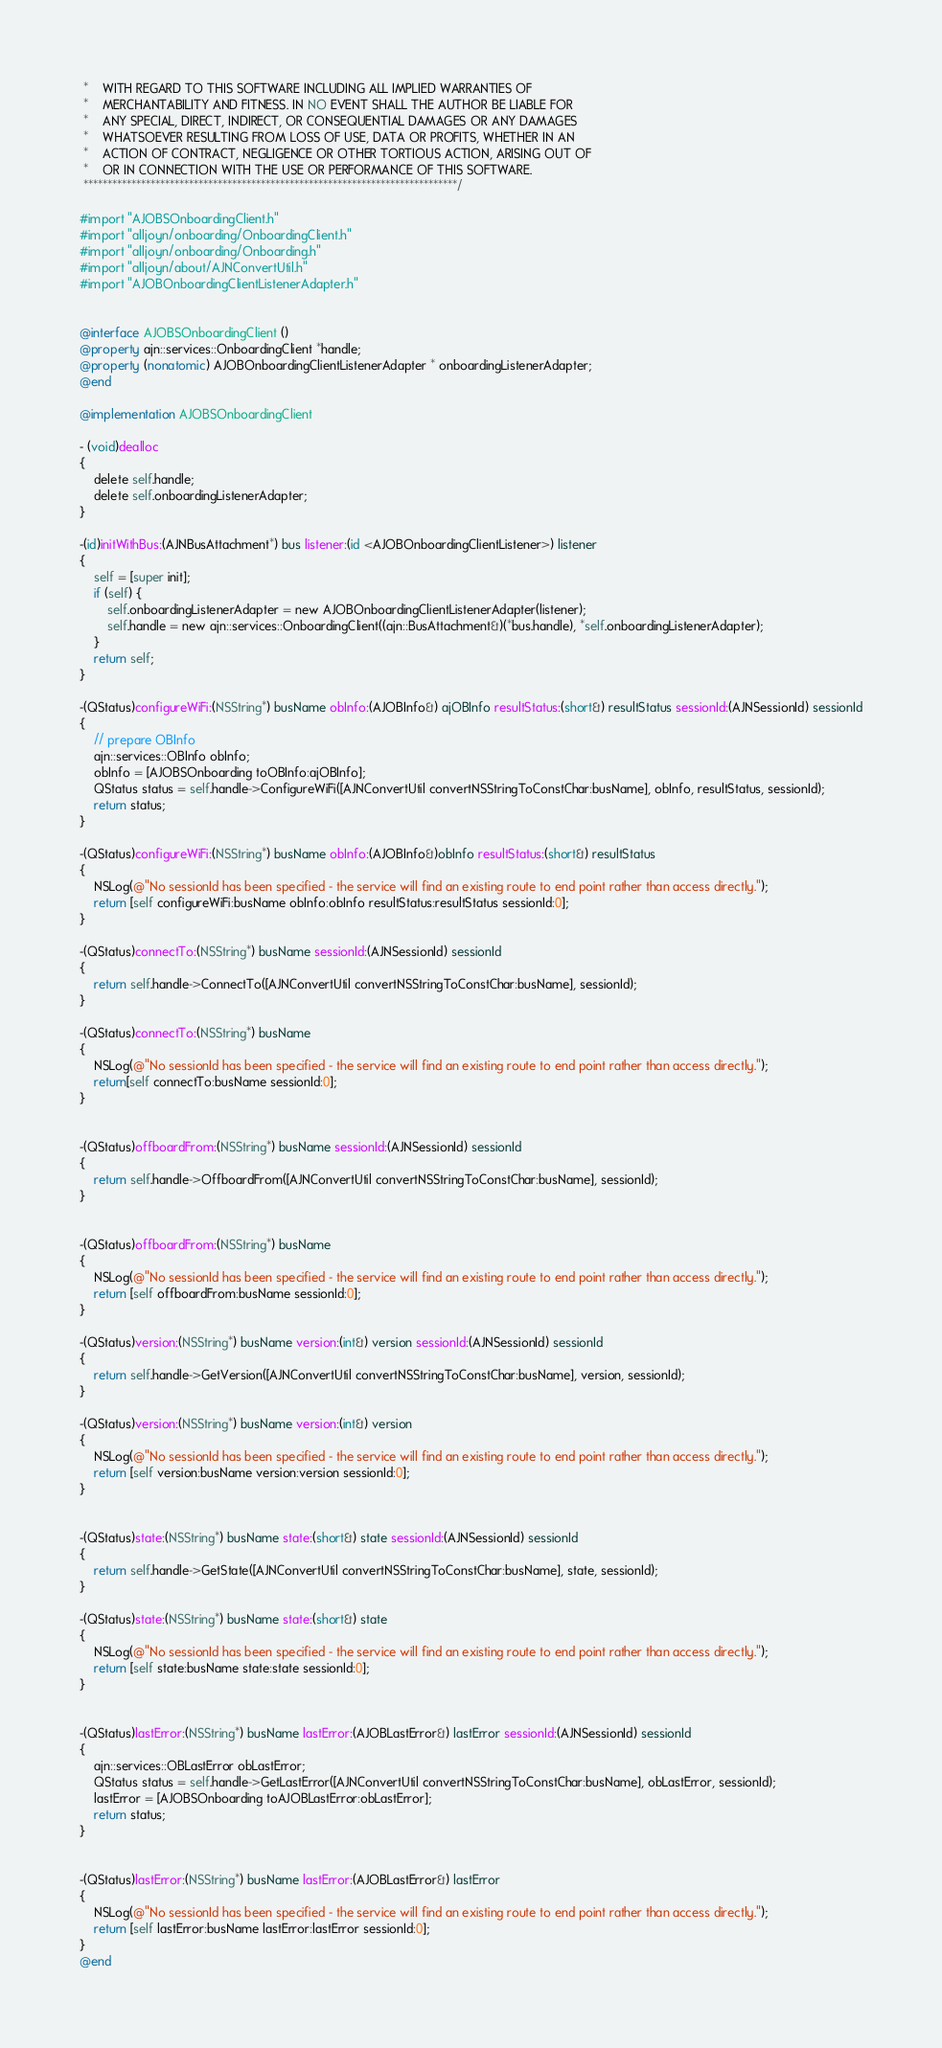<code> <loc_0><loc_0><loc_500><loc_500><_ObjectiveC_> *    WITH REGARD TO THIS SOFTWARE INCLUDING ALL IMPLIED WARRANTIES OF
 *    MERCHANTABILITY AND FITNESS. IN NO EVENT SHALL THE AUTHOR BE LIABLE FOR
 *    ANY SPECIAL, DIRECT, INDIRECT, OR CONSEQUENTIAL DAMAGES OR ANY DAMAGES
 *    WHATSOEVER RESULTING FROM LOSS OF USE, DATA OR PROFITS, WHETHER IN AN
 *    ACTION OF CONTRACT, NEGLIGENCE OR OTHER TORTIOUS ACTION, ARISING OUT OF
 *    OR IN CONNECTION WITH THE USE OR PERFORMANCE OF THIS SOFTWARE.
 ******************************************************************************/

#import "AJOBSOnboardingClient.h"
#import "alljoyn/onboarding/OnboardingClient.h"
#import "alljoyn/onboarding/Onboarding.h"
#import "alljoyn/about/AJNConvertUtil.h"
#import "AJOBOnboardingClientListenerAdapter.h"


@interface AJOBSOnboardingClient ()
@property ajn::services::OnboardingClient *handle;
@property (nonatomic) AJOBOnboardingClientListenerAdapter * onboardingListenerAdapter;
@end

@implementation AJOBSOnboardingClient

- (void)dealloc
{
    delete self.handle;
    delete self.onboardingListenerAdapter;
}

-(id)initWithBus:(AJNBusAttachment*) bus listener:(id <AJOBOnboardingClientListener>) listener
{
    self = [super init];
    if (self) {
        self.onboardingListenerAdapter = new AJOBOnboardingClientListenerAdapter(listener);
        self.handle = new ajn::services::OnboardingClient((ajn::BusAttachment&)(*bus.handle), *self.onboardingListenerAdapter);
    }
    return self;
}

-(QStatus)configureWiFi:(NSString*) busName obInfo:(AJOBInfo&) ajOBInfo resultStatus:(short&) resultStatus sessionId:(AJNSessionId) sessionId
{
    // prepare OBInfo
    ajn::services::OBInfo obInfo;
    obInfo = [AJOBSOnboarding toOBInfo:ajOBInfo];
    QStatus status = self.handle->ConfigureWiFi([AJNConvertUtil convertNSStringToConstChar:busName], obInfo, resultStatus, sessionId);
    return status;
}

-(QStatus)configureWiFi:(NSString*) busName obInfo:(AJOBInfo&)obInfo resultStatus:(short&) resultStatus
{
    NSLog(@"No sessionId has been specified - the service will find an existing route to end point rather than access directly.");
    return [self configureWiFi:busName obInfo:obInfo resultStatus:resultStatus sessionId:0];
}

-(QStatus)connectTo:(NSString*) busName sessionId:(AJNSessionId) sessionId
{
    return self.handle->ConnectTo([AJNConvertUtil convertNSStringToConstChar:busName], sessionId);
}

-(QStatus)connectTo:(NSString*) busName
{
    NSLog(@"No sessionId has been specified - the service will find an existing route to end point rather than access directly.");
    return[self connectTo:busName sessionId:0];
}


-(QStatus)offboardFrom:(NSString*) busName sessionId:(AJNSessionId) sessionId
{
    return self.handle->OffboardFrom([AJNConvertUtil convertNSStringToConstChar:busName], sessionId);
}


-(QStatus)offboardFrom:(NSString*) busName
{
    NSLog(@"No sessionId has been specified - the service will find an existing route to end point rather than access directly.");
    return [self offboardFrom:busName sessionId:0];
}

-(QStatus)version:(NSString*) busName version:(int&) version sessionId:(AJNSessionId) sessionId
{
    return self.handle->GetVersion([AJNConvertUtil convertNSStringToConstChar:busName], version, sessionId);
}

-(QStatus)version:(NSString*) busName version:(int&) version
{
    NSLog(@"No sessionId has been specified - the service will find an existing route to end point rather than access directly.");
    return [self version:busName version:version sessionId:0];
}


-(QStatus)state:(NSString*) busName state:(short&) state sessionId:(AJNSessionId) sessionId
{
    return self.handle->GetState([AJNConvertUtil convertNSStringToConstChar:busName], state, sessionId);
}

-(QStatus)state:(NSString*) busName state:(short&) state
{
    NSLog(@"No sessionId has been specified - the service will find an existing route to end point rather than access directly.");
    return [self state:busName state:state sessionId:0];
}


-(QStatus)lastError:(NSString*) busName lastError:(AJOBLastError&) lastError sessionId:(AJNSessionId) sessionId
{
    ajn::services::OBLastError obLastError;
    QStatus status = self.handle->GetLastError([AJNConvertUtil convertNSStringToConstChar:busName], obLastError, sessionId);
    lastError = [AJOBSOnboarding toAJOBLastError:obLastError];
    return status;
}


-(QStatus)lastError:(NSString*) busName lastError:(AJOBLastError&) lastError
{
    NSLog(@"No sessionId has been specified - the service will find an existing route to end point rather than access directly.");
    return [self lastError:busName lastError:lastError sessionId:0];
}
@end
</code> 